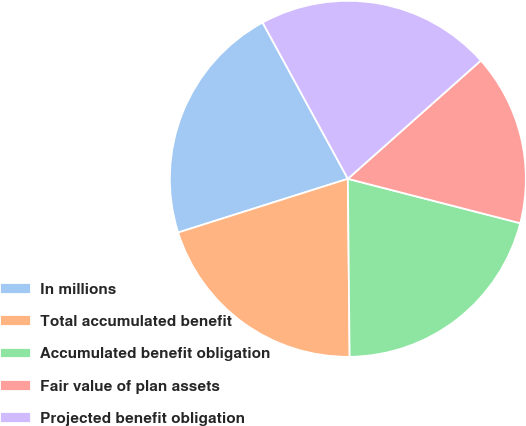<chart> <loc_0><loc_0><loc_500><loc_500><pie_chart><fcel>In millions<fcel>Total accumulated benefit<fcel>Accumulated benefit obligation<fcel>Fair value of plan assets<fcel>Projected benefit obligation<nl><fcel>21.93%<fcel>20.28%<fcel>20.83%<fcel>15.58%<fcel>21.38%<nl></chart> 